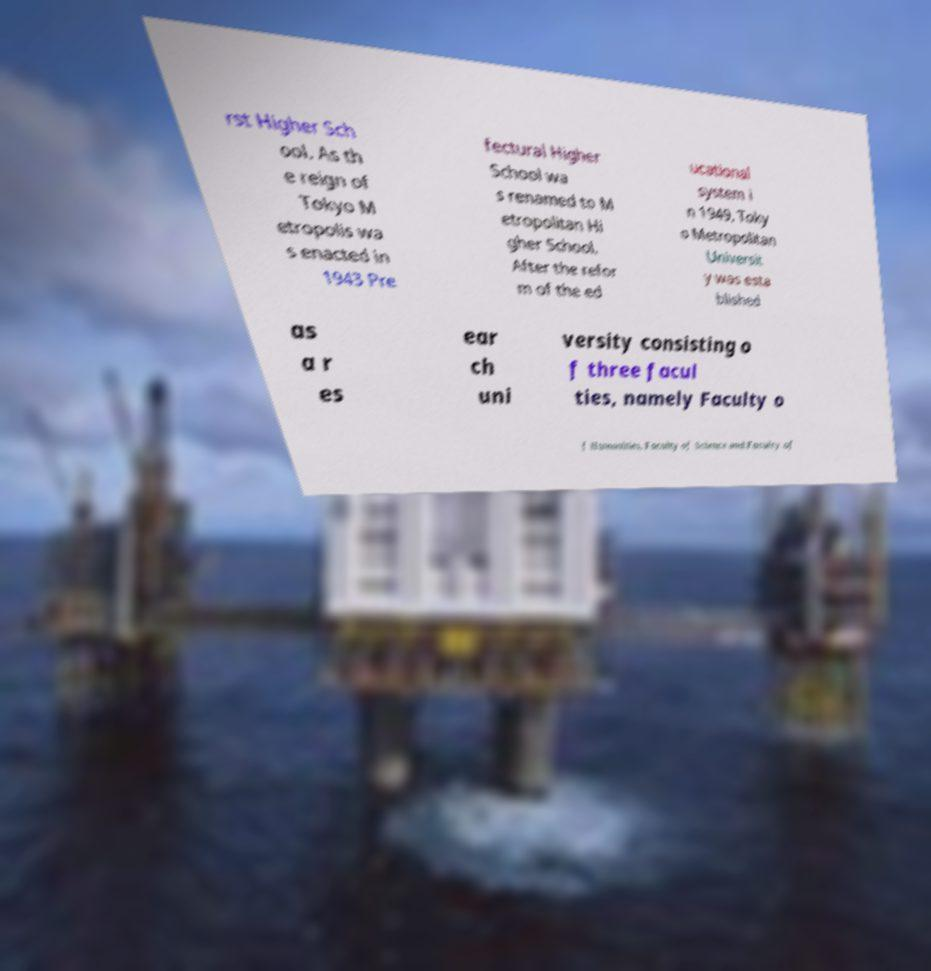Can you accurately transcribe the text from the provided image for me? rst Higher Sch ool. As th e reign of Tokyo M etropolis wa s enacted in 1943 Pre fectural Higher School wa s renamed to M etropolitan Hi gher School. After the refor m of the ed ucational system i n 1949, Toky o Metropolitan Universit y was esta blished as a r es ear ch uni versity consisting o f three facul ties, namely Faculty o f Humanities, Faculty of Science and Faculty of 